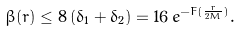Convert formula to latex. <formula><loc_0><loc_0><loc_500><loc_500>\beta ( r ) \leq 8 \, ( \delta _ { 1 } + \delta _ { 2 } ) = 1 6 \, e ^ { - F ( \frac { r } { 2 M } ) } .</formula> 